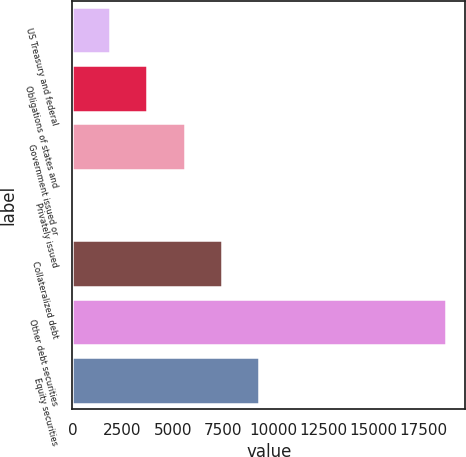Convert chart to OTSL. <chart><loc_0><loc_0><loc_500><loc_500><bar_chart><fcel>US Treasury and federal<fcel>Obligations of states and<fcel>Government issued or<fcel>Privately issued<fcel>Collateralized debt<fcel>Other debt securities<fcel>Equity securities<nl><fcel>1867.5<fcel>3732<fcel>5596.5<fcel>3<fcel>7461<fcel>18648<fcel>9325.5<nl></chart> 